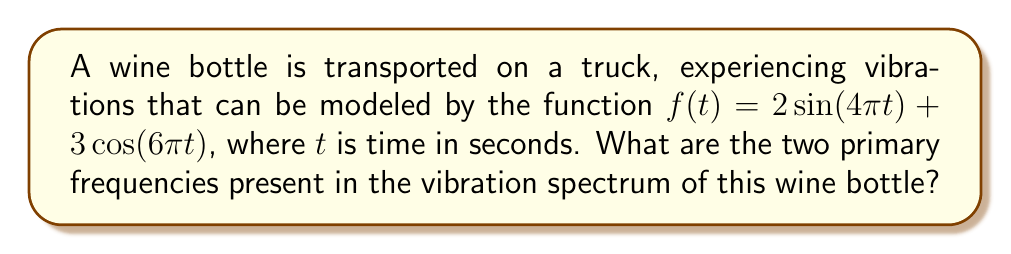Solve this math problem. To find the primary frequencies in the vibration spectrum, we need to analyze the given function:

$f(t) = 2\sin(4\pi t) + 3\cos(6\pi t)$

1. For a sinusoidal function of the form $\sin(\omega t)$ or $\cos(\omega t)$, the angular frequency is $\omega$ radians per second.

2. The frequency $f$ in Hz is related to $\omega$ by the equation:
   $f = \frac{\omega}{2\pi}$

3. For the first term, $2\sin(4\pi t)$:
   $\omega_1 = 4\pi$
   $f_1 = \frac{4\pi}{2\pi} = 2$ Hz

4. For the second term, $3\cos(6\pi t)$:
   $\omega_2 = 6\pi$
   $f_2 = \frac{6\pi}{2\pi} = 3$ Hz

Therefore, the two primary frequencies in the vibration spectrum are 2 Hz and 3 Hz.
Answer: 2 Hz and 3 Hz 